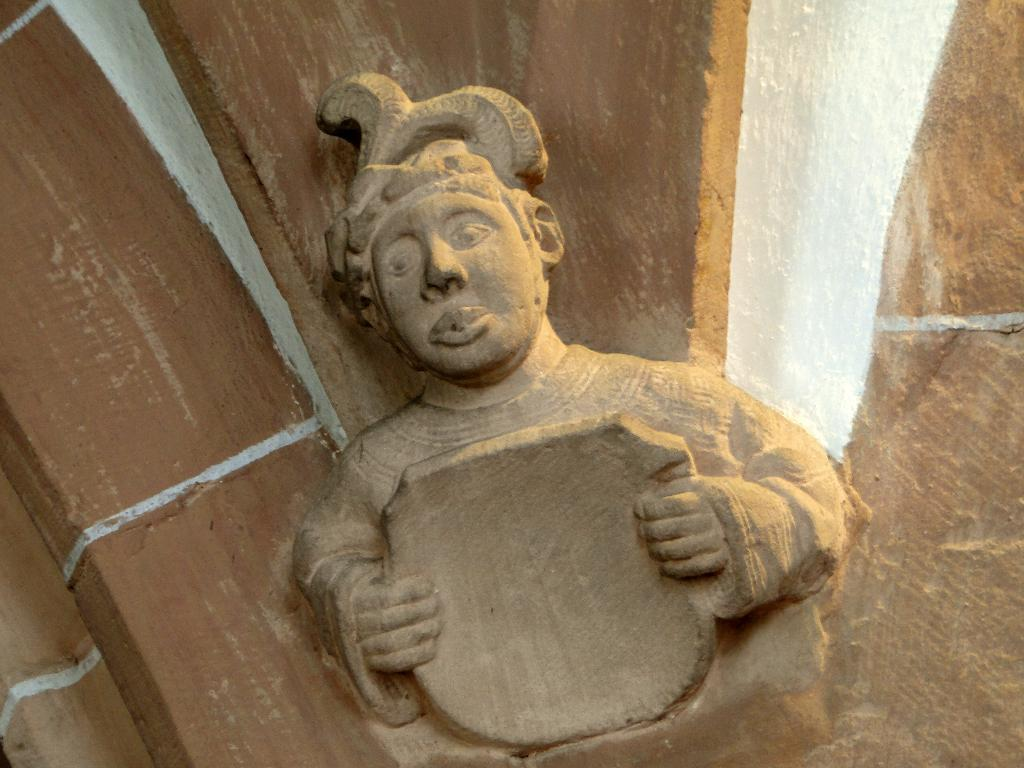What is the main subject of the image? There is a sculpture in the image. What does the sculpture depict? The sculpture depicts a person. What is the person in the sculpture doing? The person in the sculpture is holding an object. Can you tell me how many horses are depicted in the sculpture? There are no horses depicted in the sculpture; it features a person holding an object. What type of expression is the person in the sculpture displaying on their stomach? The sculpture does not depict a person with a stomach or any facial expressions, as it is a static object. 